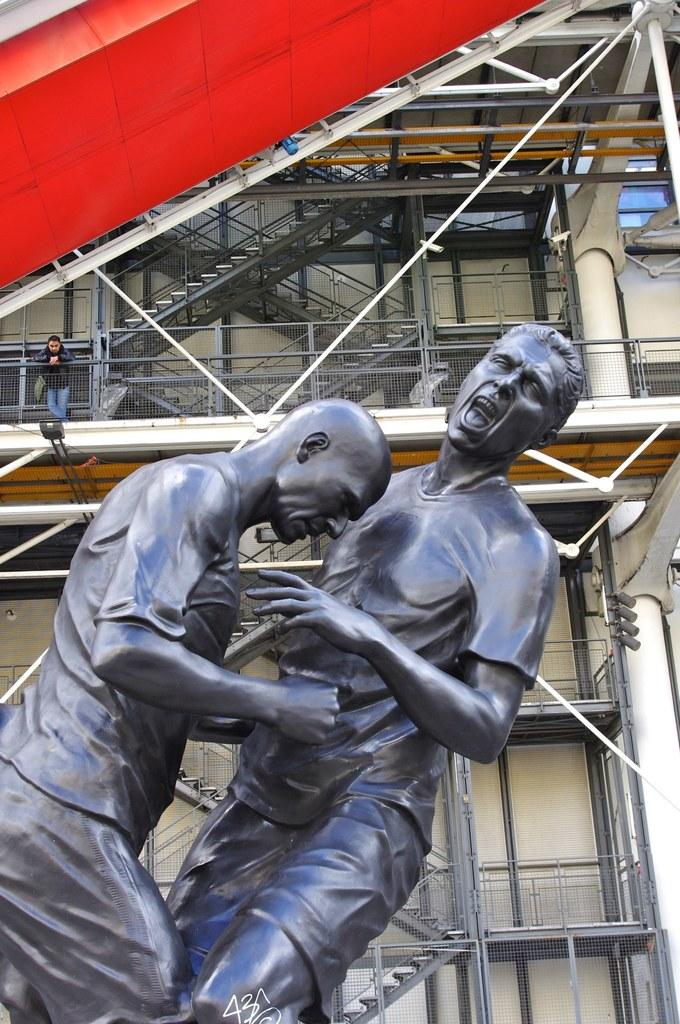What can be seen in the image that represents people? There are statues of two men in the image. What type of structure is visible in the background of the image? There is a building in the background of the image. What architectural feature can be seen in the background of the image? There are stairs in the background of the image. What is the man near in the image? The man is standing near the railing in the image. What type of breakfast is being served in the image? There is no breakfast present in the image; it features statues of two men, a building, stairs, and a man standing near the railing. 